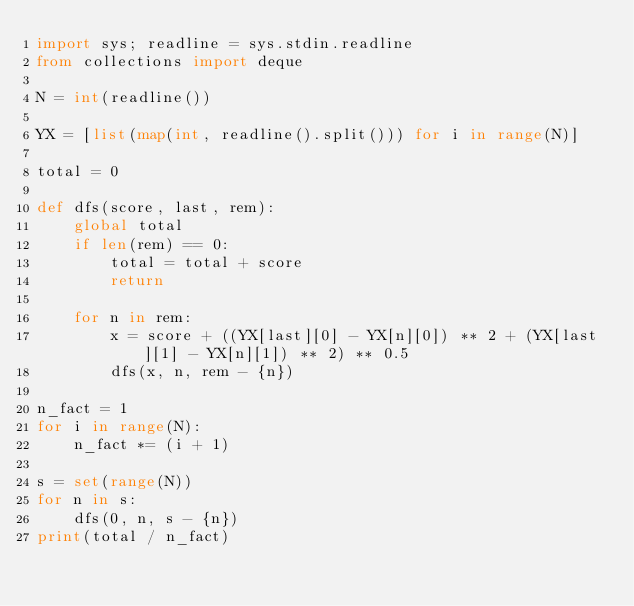<code> <loc_0><loc_0><loc_500><loc_500><_Python_>import sys; readline = sys.stdin.readline
from collections import deque

N = int(readline())

YX = [list(map(int, readline().split())) for i in range(N)]

total = 0

def dfs(score, last, rem):
    global total
    if len(rem) == 0:
        total = total + score
        return
    
    for n in rem:
        x = score + ((YX[last][0] - YX[n][0]) ** 2 + (YX[last][1] - YX[n][1]) ** 2) ** 0.5
        dfs(x, n, rem - {n})

n_fact = 1
for i in range(N):
    n_fact *= (i + 1)

s = set(range(N))
for n in s:
    dfs(0, n, s - {n})
print(total / n_fact)</code> 